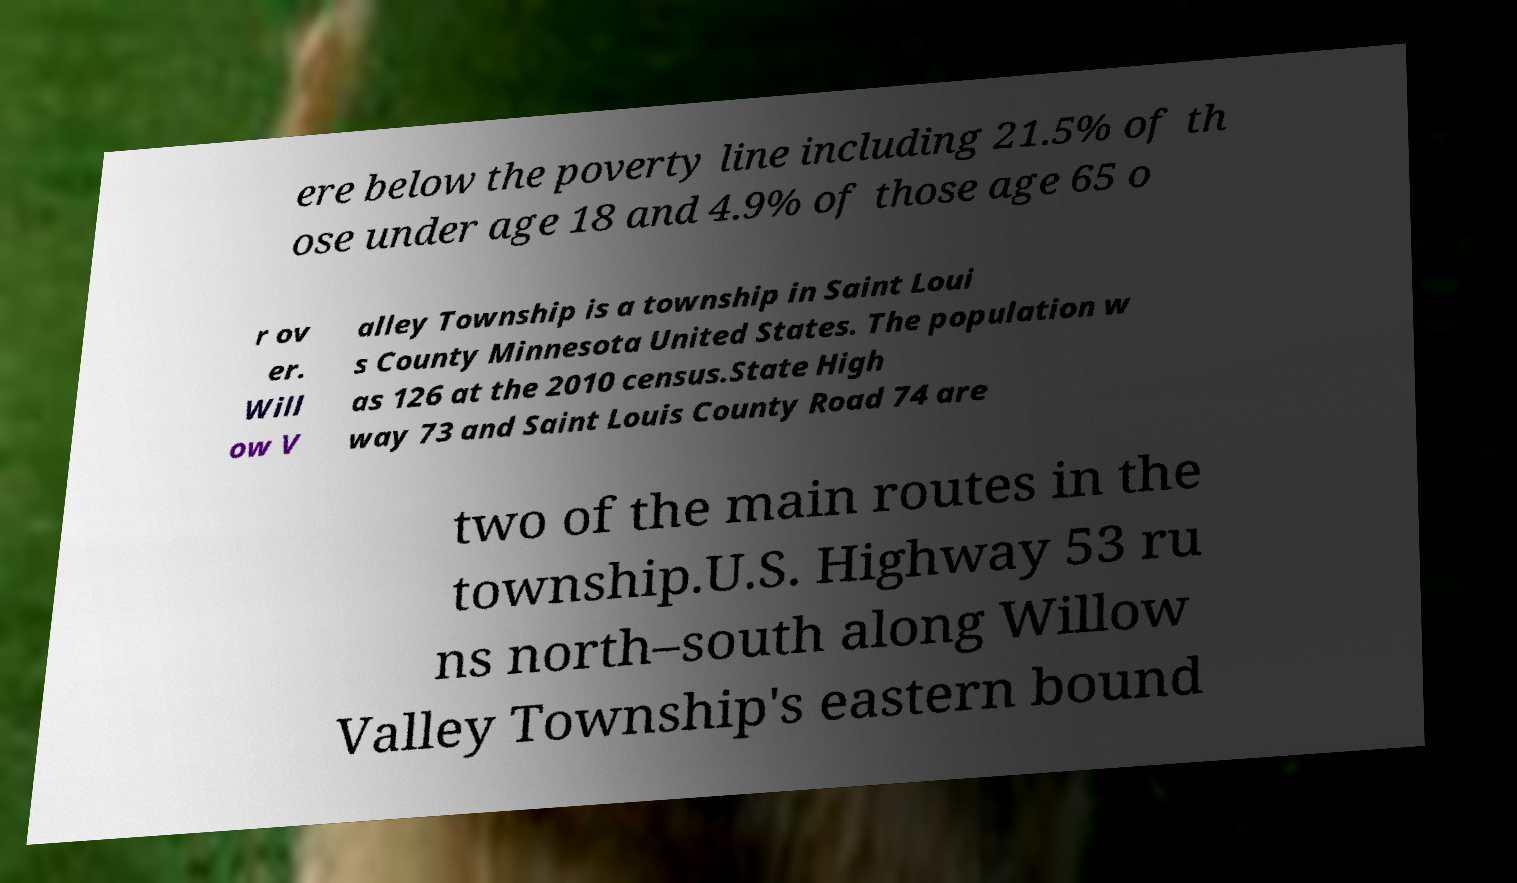Please read and relay the text visible in this image. What does it say? ere below the poverty line including 21.5% of th ose under age 18 and 4.9% of those age 65 o r ov er. Will ow V alley Township is a township in Saint Loui s County Minnesota United States. The population w as 126 at the 2010 census.State High way 73 and Saint Louis County Road 74 are two of the main routes in the township.U.S. Highway 53 ru ns north–south along Willow Valley Township's eastern bound 